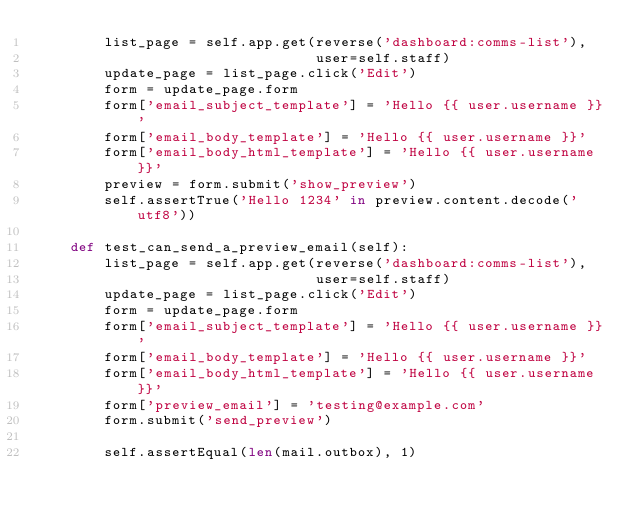Convert code to text. <code><loc_0><loc_0><loc_500><loc_500><_Python_>        list_page = self.app.get(reverse('dashboard:comms-list'),
                                 user=self.staff)
        update_page = list_page.click('Edit')
        form = update_page.form
        form['email_subject_template'] = 'Hello {{ user.username }}'
        form['email_body_template'] = 'Hello {{ user.username }}'
        form['email_body_html_template'] = 'Hello {{ user.username }}'
        preview = form.submit('show_preview')
        self.assertTrue('Hello 1234' in preview.content.decode('utf8'))

    def test_can_send_a_preview_email(self):
        list_page = self.app.get(reverse('dashboard:comms-list'),
                                 user=self.staff)
        update_page = list_page.click('Edit')
        form = update_page.form
        form['email_subject_template'] = 'Hello {{ user.username }}'
        form['email_body_template'] = 'Hello {{ user.username }}'
        form['email_body_html_template'] = 'Hello {{ user.username }}'
        form['preview_email'] = 'testing@example.com'
        form.submit('send_preview')

        self.assertEqual(len(mail.outbox), 1)
</code> 